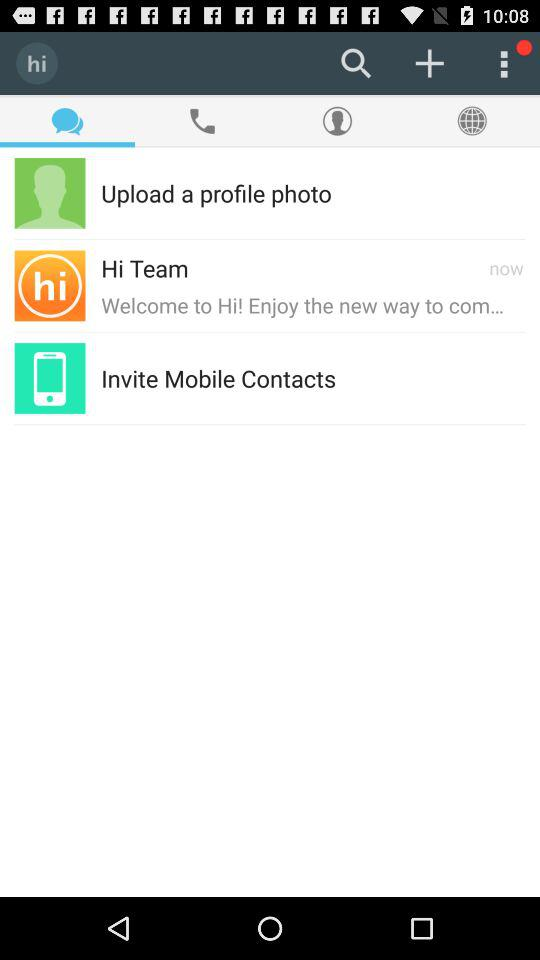What is the application name? The application name is "hi". 